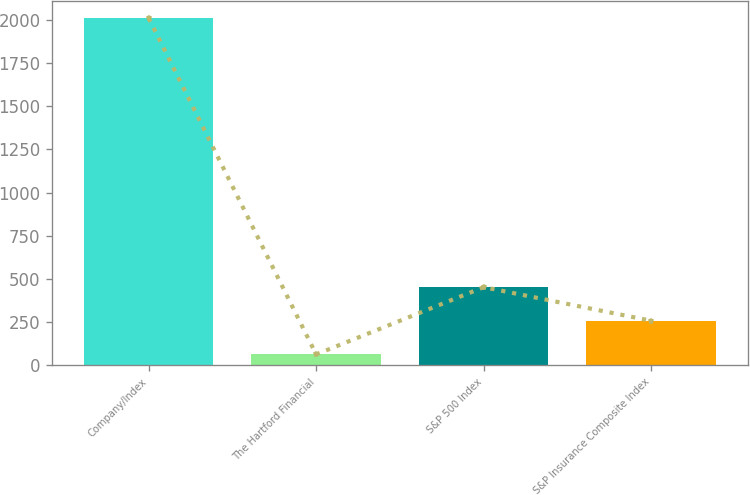<chart> <loc_0><loc_0><loc_500><loc_500><bar_chart><fcel>Company/Index<fcel>The Hartford Financial<fcel>S&P 500 Index<fcel>S&P Insurance Composite Index<nl><fcel>2011<fcel>62.45<fcel>452.17<fcel>257.31<nl></chart> 